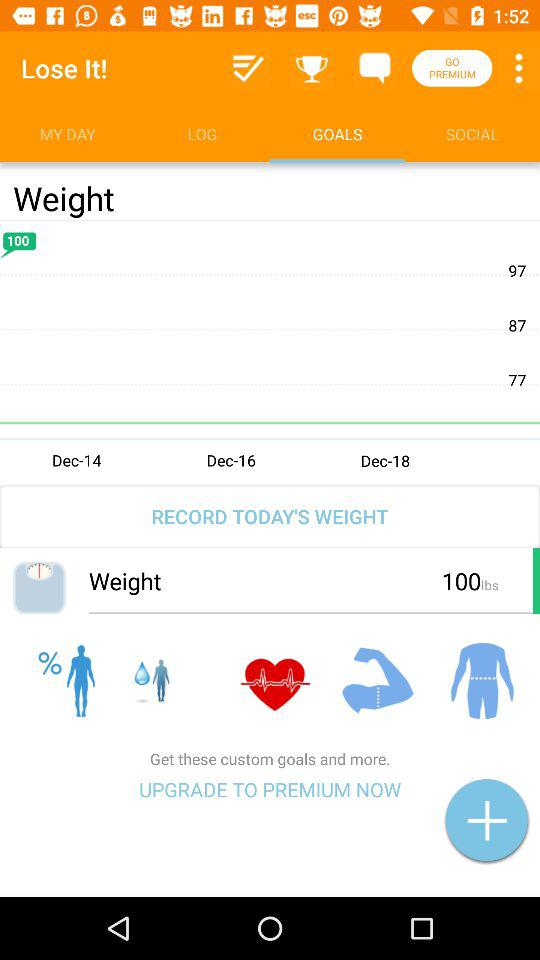How much is today's weight? Today's weight is 100 lbs. 